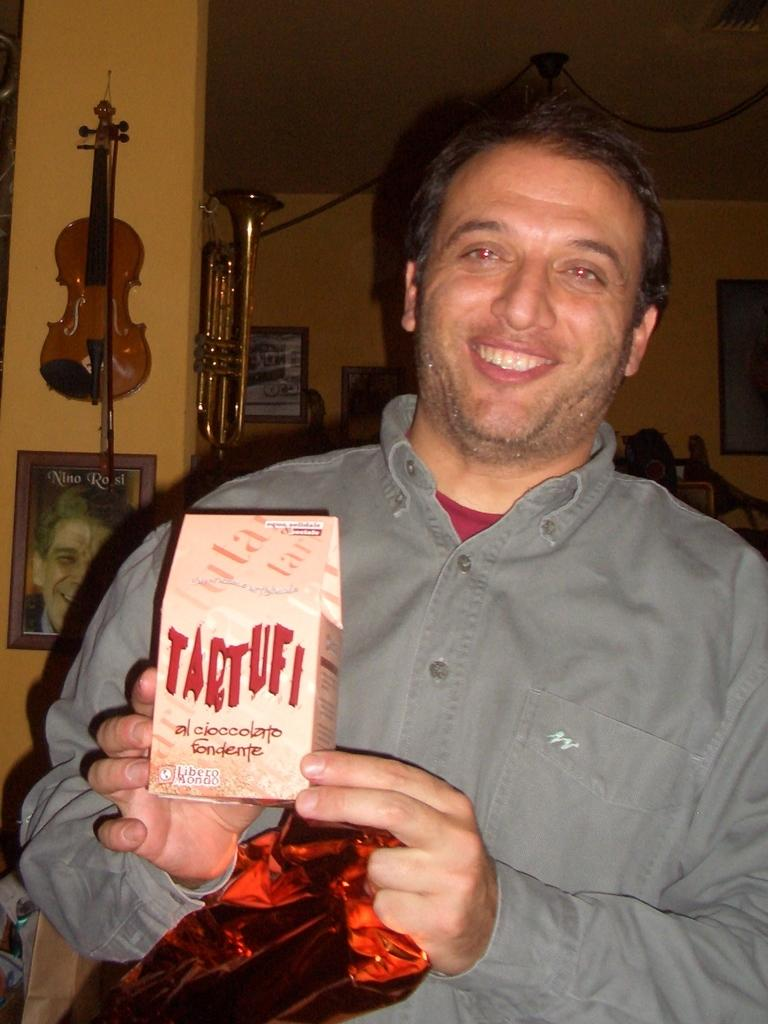What is the man in the image doing? The man is holding an object and smiling. Can you describe the object the man is holding? The provided facts do not specify the object the man is holding. What can be seen in the background of the image? There is a violin, a photo frame, and an alto saxophone in the background of the image. How many teeth can be seen in the image? There is no reference to teeth in the image, so it is not possible to determine how many teeth are visible. 